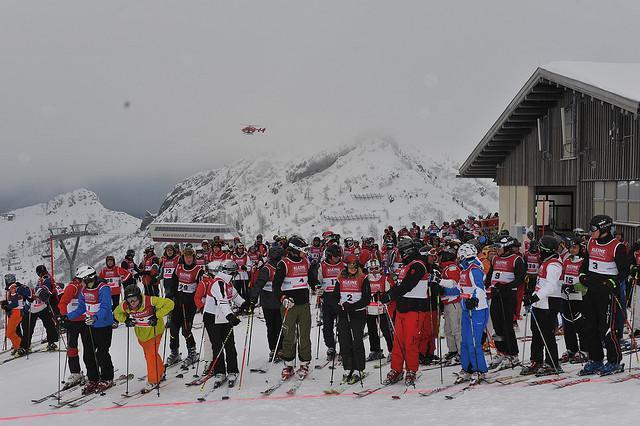How many people are in the picture?
Give a very brief answer. 10. How many boats are in the water?
Give a very brief answer. 0. 